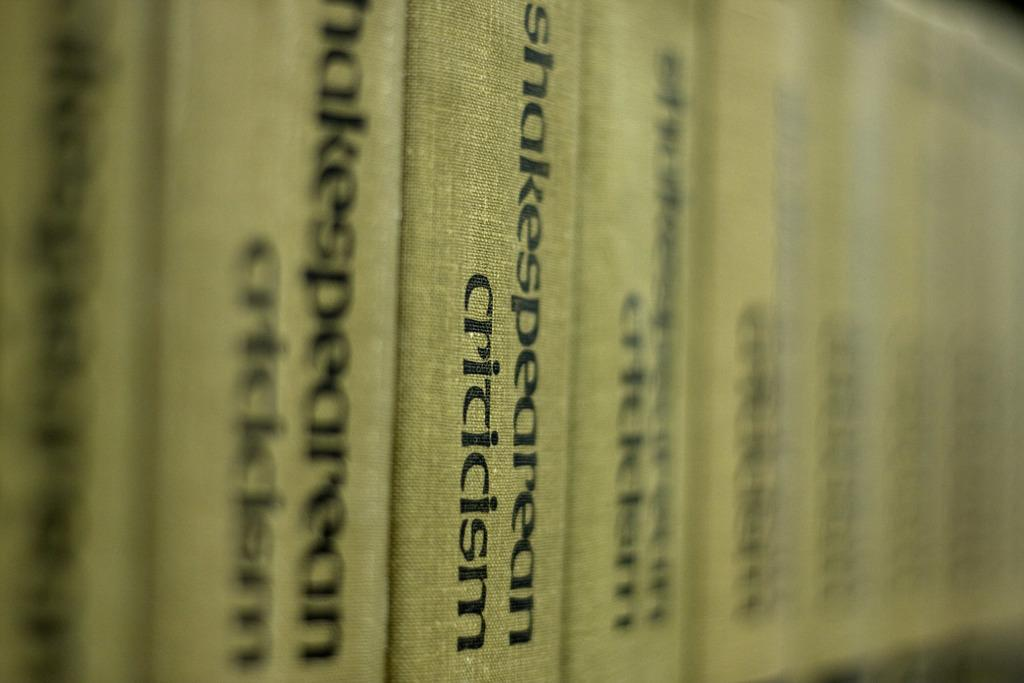<image>
Provide a brief description of the given image. Volumes of Shakespearean Criticisms are lined up in a row. 